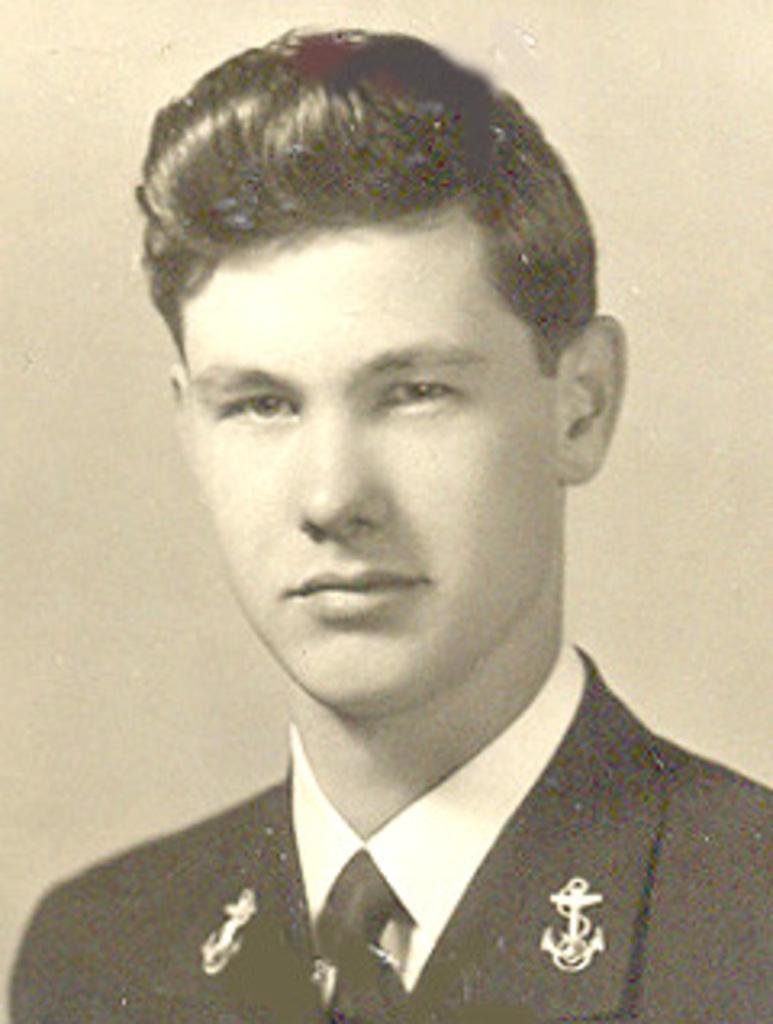In one or two sentences, can you explain what this image depicts? In this image I can see a person's photo and a wall. This image looks like a photo frame. 